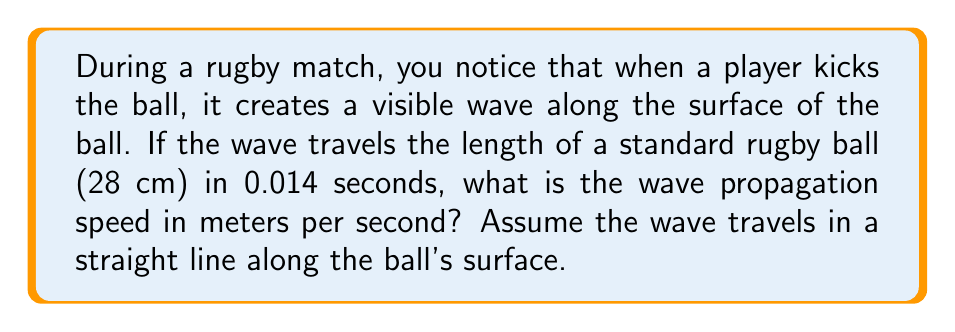Solve this math problem. To solve this problem, we'll use the fundamental equation relating speed, distance, and time:

$$v = \frac{d}{t}$$

Where:
$v$ = wave propagation speed (m/s)
$d$ = distance traveled (m)
$t$ = time taken (s)

Step 1: Convert the ball's length from centimeters to meters.
$$d = 28 \text{ cm} = 0.28 \text{ m}$$

Step 2: Use the given time.
$$t = 0.014 \text{ s}$$

Step 3: Substitute these values into the equation:

$$v = \frac{d}{t} = \frac{0.28 \text{ m}}{0.014 \text{ s}}$$

Step 4: Calculate the result:

$$v = 20 \text{ m/s}$$

Therefore, the wave propagation speed along the surface of the rugby ball is 20 meters per second.
Answer: $20 \text{ m/s}$ 